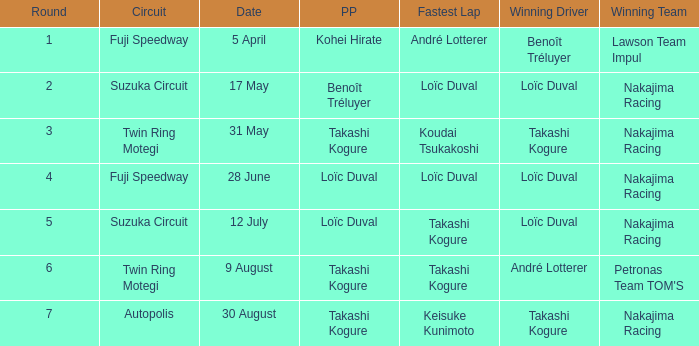How many drivers drove on Suzuka Circuit where Loïc Duval took pole position? 1.0. 